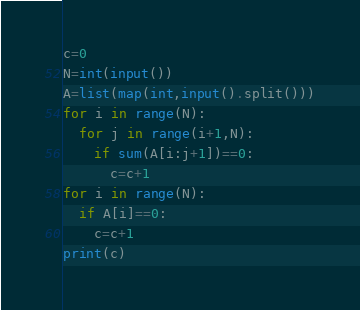Convert code to text. <code><loc_0><loc_0><loc_500><loc_500><_Python_>c=0
N=int(input())
A=list(map(int,input().split()))
for i in range(N):
  for j in range(i+1,N):
    if sum(A[i:j+1])==0:
      c=c+1
for i in range(N):
  if A[i]==0:
    c=c+1
print(c)</code> 